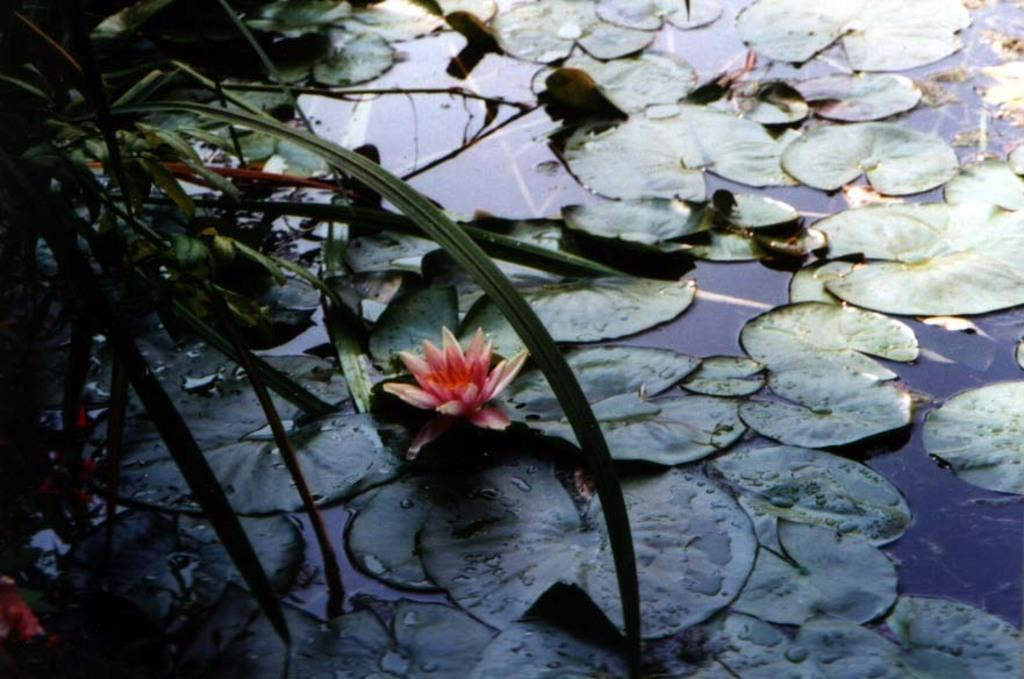What is the color of the leaves on the water? The leaves on the water are green in color. What can be found among the green leaves? There is a flower in between the leaves. What type of lift can be seen in the image? There is no lift present in the image; it features green leaves and a flower on the water. What is the neck size of the flower in the image? The flower in the image does not have a neck, and its size cannot be determined from the image. 